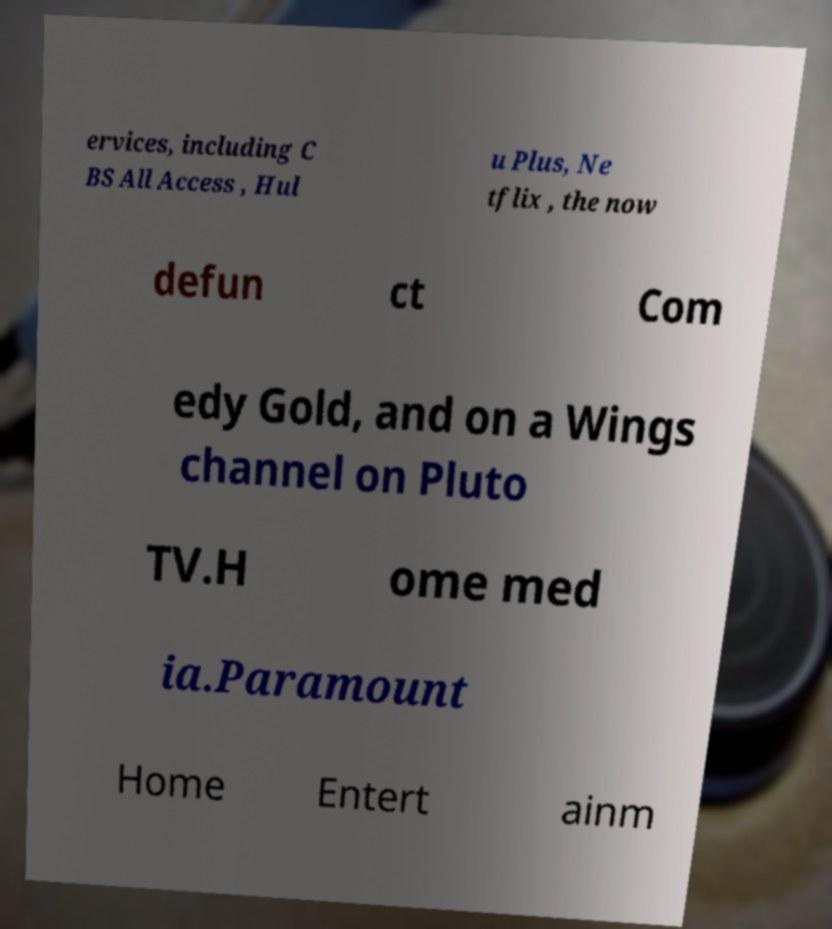For documentation purposes, I need the text within this image transcribed. Could you provide that? ervices, including C BS All Access , Hul u Plus, Ne tflix , the now defun ct Com edy Gold, and on a Wings channel on Pluto TV.H ome med ia.Paramount Home Entert ainm 